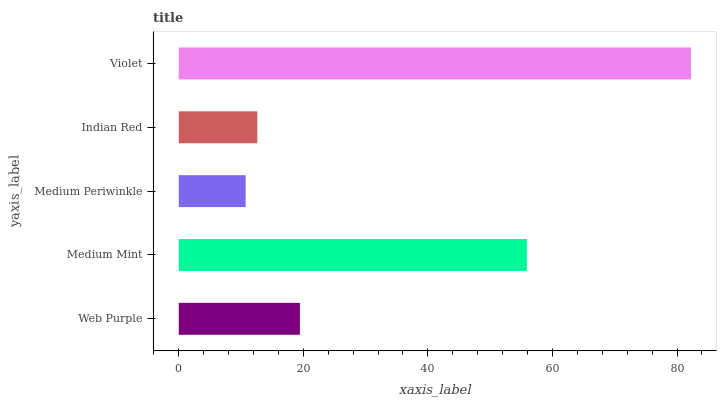Is Medium Periwinkle the minimum?
Answer yes or no. Yes. Is Violet the maximum?
Answer yes or no. Yes. Is Medium Mint the minimum?
Answer yes or no. No. Is Medium Mint the maximum?
Answer yes or no. No. Is Medium Mint greater than Web Purple?
Answer yes or no. Yes. Is Web Purple less than Medium Mint?
Answer yes or no. Yes. Is Web Purple greater than Medium Mint?
Answer yes or no. No. Is Medium Mint less than Web Purple?
Answer yes or no. No. Is Web Purple the high median?
Answer yes or no. Yes. Is Web Purple the low median?
Answer yes or no. Yes. Is Indian Red the high median?
Answer yes or no. No. Is Medium Mint the low median?
Answer yes or no. No. 